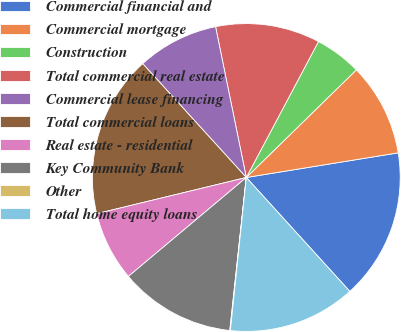Convert chart to OTSL. <chart><loc_0><loc_0><loc_500><loc_500><pie_chart><fcel>Commercial financial and<fcel>Commercial mortgage<fcel>Construction<fcel>Total commercial real estate<fcel>Commercial lease financing<fcel>Total commercial loans<fcel>Real estate - residential<fcel>Key Community Bank<fcel>Other<fcel>Total home equity loans<nl><fcel>15.82%<fcel>9.76%<fcel>4.91%<fcel>10.97%<fcel>8.55%<fcel>17.03%<fcel>7.33%<fcel>12.18%<fcel>0.06%<fcel>13.39%<nl></chart> 